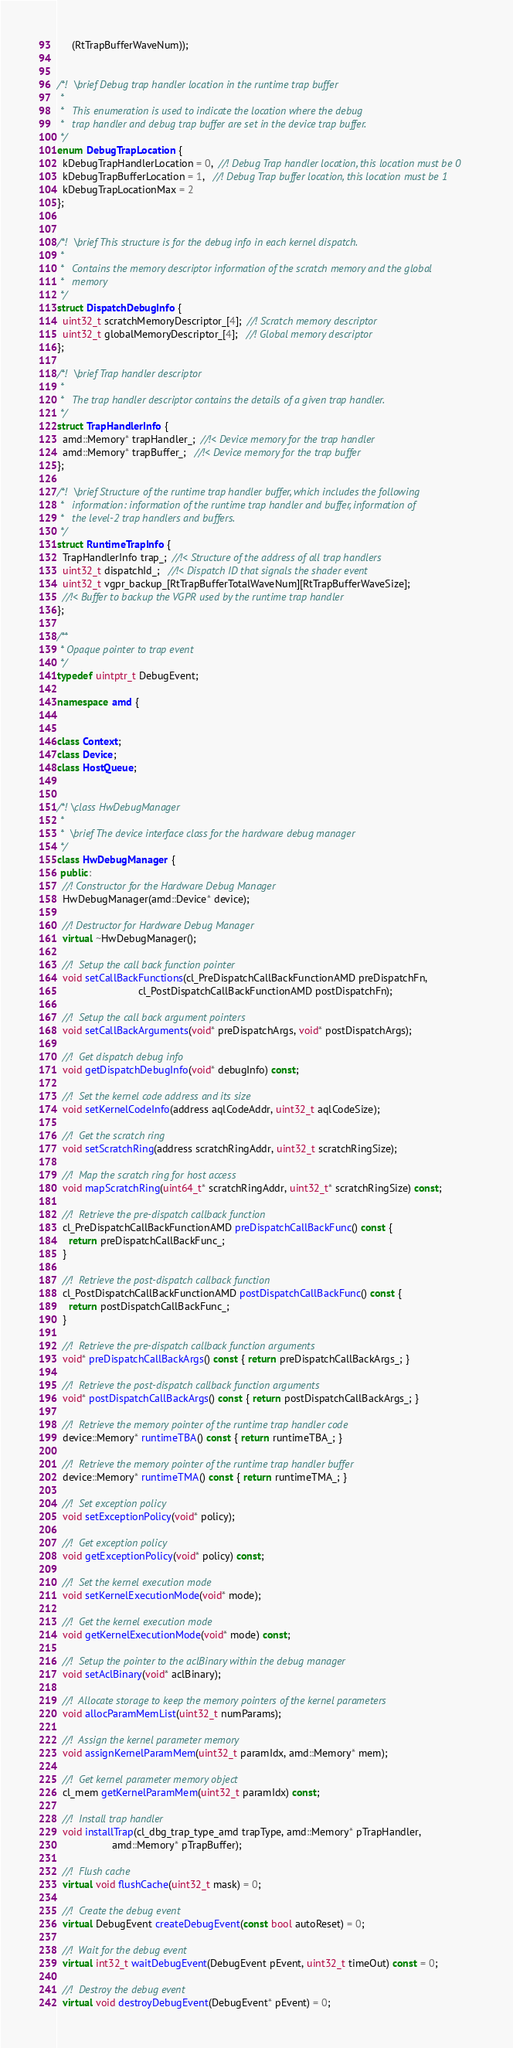Convert code to text. <code><loc_0><loc_0><loc_500><loc_500><_C++_>     (RtTrapBufferWaveNum));


/*!  \brief Debug trap handler location in the runtime trap buffer
 *
 *   This enumeration is used to indicate the location where the debug
 *   trap handler and debug trap buffer are set in the device trap buffer.
 */
enum DebugTrapLocation {
  kDebugTrapHandlerLocation = 0,  //! Debug Trap handler location, this location must be 0
  kDebugTrapBufferLocation = 1,   //! Debug Trap buffer location, this location must be 1
  kDebugTrapLocationMax = 2
};


/*!  \brief This structure is for the debug info in each kernel dispatch.
 *
 *   Contains the memory descriptor information of the scratch memory and the global
 *   memory
 */
struct DispatchDebugInfo {
  uint32_t scratchMemoryDescriptor_[4];  //! Scratch memory descriptor
  uint32_t globalMemoryDescriptor_[4];   //! Global memory descriptor
};

/*!  \brief Trap handler descriptor
 *
 *   The trap handler descriptor contains the details of a given trap handler.
 */
struct TrapHandlerInfo {
  amd::Memory* trapHandler_;  //!< Device memory for the trap handler
  amd::Memory* trapBuffer_;   //!< Device memory for the trap buffer
};

/*!  \brief Structure of the runtime trap handler buffer, which includes the following
 *   information: information of the runtime trap handler and buffer, information of
 *   the level-2 trap handlers and buffers.
 */
struct RuntimeTrapInfo {
  TrapHandlerInfo trap_;  //!< Structure of the address of all trap handlers
  uint32_t dispatchId_;   //!< Dispatch ID that signals the shader event
  uint32_t vgpr_backup_[RtTrapBufferTotalWaveNum][RtTrapBufferWaveSize];
  //!< Buffer to backup the VGPR used by the runtime trap handler
};

/**
 * Opaque pointer to trap event
 */
typedef uintptr_t DebugEvent;

namespace amd {


class Context;
class Device;
class HostQueue;


/*! \class HwDebugManager
 *
 *  \brief The device interface class for the hardware debug manager
 */
class HwDebugManager {
 public:
  //! Constructor for the Hardware Debug Manager
  HwDebugManager(amd::Device* device);

  //! Destructor for Hardware Debug Manager
  virtual ~HwDebugManager();

  //!  Setup the call back function pointer
  void setCallBackFunctions(cl_PreDispatchCallBackFunctionAMD preDispatchFn,
                            cl_PostDispatchCallBackFunctionAMD postDispatchFn);

  //!  Setup the call back argument pointers
  void setCallBackArguments(void* preDispatchArgs, void* postDispatchArgs);

  //!  Get dispatch debug info
  void getDispatchDebugInfo(void* debugInfo) const;

  //!  Set the kernel code address and its size
  void setKernelCodeInfo(address aqlCodeAddr, uint32_t aqlCodeSize);

  //!  Get the scratch ring
  void setScratchRing(address scratchRingAddr, uint32_t scratchRingSize);

  //!  Map the scratch ring for host access
  void mapScratchRing(uint64_t* scratchRingAddr, uint32_t* scratchRingSize) const;

  //!  Retrieve the pre-dispatch callback function
  cl_PreDispatchCallBackFunctionAMD preDispatchCallBackFunc() const {
    return preDispatchCallBackFunc_;
  }

  //!  Retrieve the post-dispatch callback function
  cl_PostDispatchCallBackFunctionAMD postDispatchCallBackFunc() const {
    return postDispatchCallBackFunc_;
  }

  //!  Retrieve the pre-dispatch callback function arguments
  void* preDispatchCallBackArgs() const { return preDispatchCallBackArgs_; }

  //!  Retrieve the post-dispatch callback function arguments
  void* postDispatchCallBackArgs() const { return postDispatchCallBackArgs_; }

  //!  Retrieve the memory pointer of the runtime trap handler code
  device::Memory* runtimeTBA() const { return runtimeTBA_; }

  //!  Retrieve the memory pointer of the runtime trap handler buffer
  device::Memory* runtimeTMA() const { return runtimeTMA_; }

  //!  Set exception policy
  void setExceptionPolicy(void* policy);

  //!  Get exception policy
  void getExceptionPolicy(void* policy) const;

  //!  Set the kernel execution mode
  void setKernelExecutionMode(void* mode);

  //!  Get the kernel execution mode
  void getKernelExecutionMode(void* mode) const;

  //!  Setup the pointer to the aclBinary within the debug manager
  void setAclBinary(void* aclBinary);

  //!  Allocate storage to keep the memory pointers of the kernel parameters
  void allocParamMemList(uint32_t numParams);

  //!  Assign the kernel parameter memory
  void assignKernelParamMem(uint32_t paramIdx, amd::Memory* mem);

  //!  Get kernel parameter memory object
  cl_mem getKernelParamMem(uint32_t paramIdx) const;

  //!  Install trap handler
  void installTrap(cl_dbg_trap_type_amd trapType, amd::Memory* pTrapHandler,
                   amd::Memory* pTrapBuffer);

  //!  Flush cache
  virtual void flushCache(uint32_t mask) = 0;

  //!  Create the debug event
  virtual DebugEvent createDebugEvent(const bool autoReset) = 0;

  //!  Wait for the debug event
  virtual int32_t waitDebugEvent(DebugEvent pEvent, uint32_t timeOut) const = 0;

  //!  Destroy the debug event
  virtual void destroyDebugEvent(DebugEvent* pEvent) = 0;
</code> 